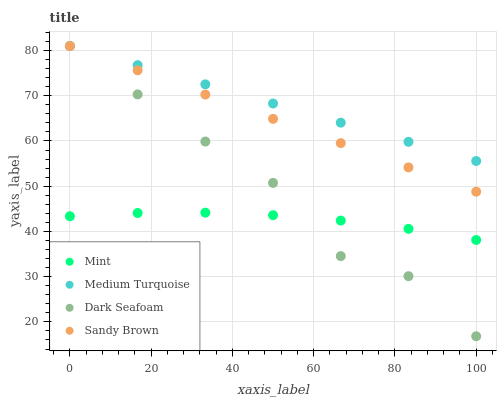Does Mint have the minimum area under the curve?
Answer yes or no. Yes. Does Medium Turquoise have the maximum area under the curve?
Answer yes or no. Yes. Does Dark Seafoam have the minimum area under the curve?
Answer yes or no. No. Does Dark Seafoam have the maximum area under the curve?
Answer yes or no. No. Is Medium Turquoise the smoothest?
Answer yes or no. Yes. Is Dark Seafoam the roughest?
Answer yes or no. Yes. Is Mint the smoothest?
Answer yes or no. No. Is Mint the roughest?
Answer yes or no. No. Does Dark Seafoam have the lowest value?
Answer yes or no. Yes. Does Mint have the lowest value?
Answer yes or no. No. Does Medium Turquoise have the highest value?
Answer yes or no. Yes. Does Mint have the highest value?
Answer yes or no. No. Is Mint less than Medium Turquoise?
Answer yes or no. Yes. Is Sandy Brown greater than Mint?
Answer yes or no. Yes. Does Dark Seafoam intersect Sandy Brown?
Answer yes or no. Yes. Is Dark Seafoam less than Sandy Brown?
Answer yes or no. No. Is Dark Seafoam greater than Sandy Brown?
Answer yes or no. No. Does Mint intersect Medium Turquoise?
Answer yes or no. No. 